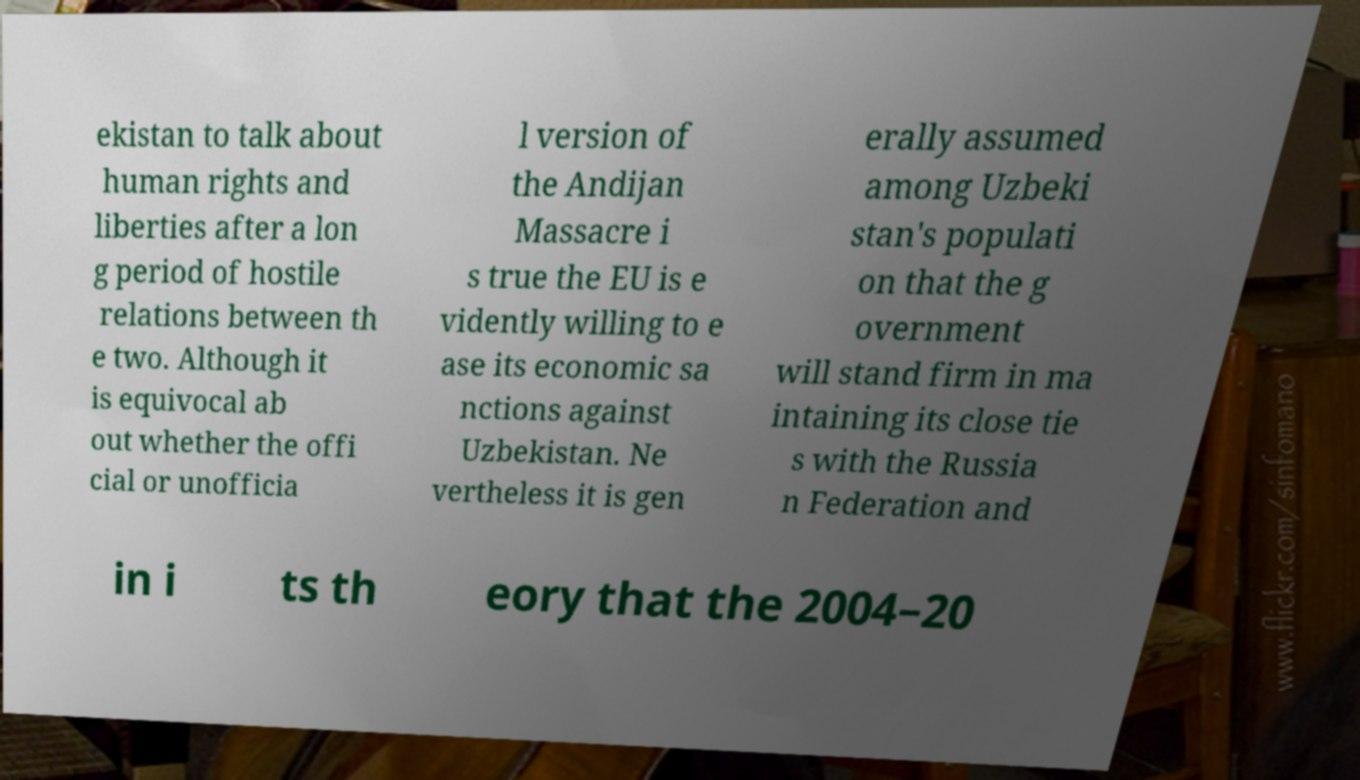Can you accurately transcribe the text from the provided image for me? ekistan to talk about human rights and liberties after a lon g period of hostile relations between th e two. Although it is equivocal ab out whether the offi cial or unofficia l version of the Andijan Massacre i s true the EU is e vidently willing to e ase its economic sa nctions against Uzbekistan. Ne vertheless it is gen erally assumed among Uzbeki stan's populati on that the g overnment will stand firm in ma intaining its close tie s with the Russia n Federation and in i ts th eory that the 2004–20 